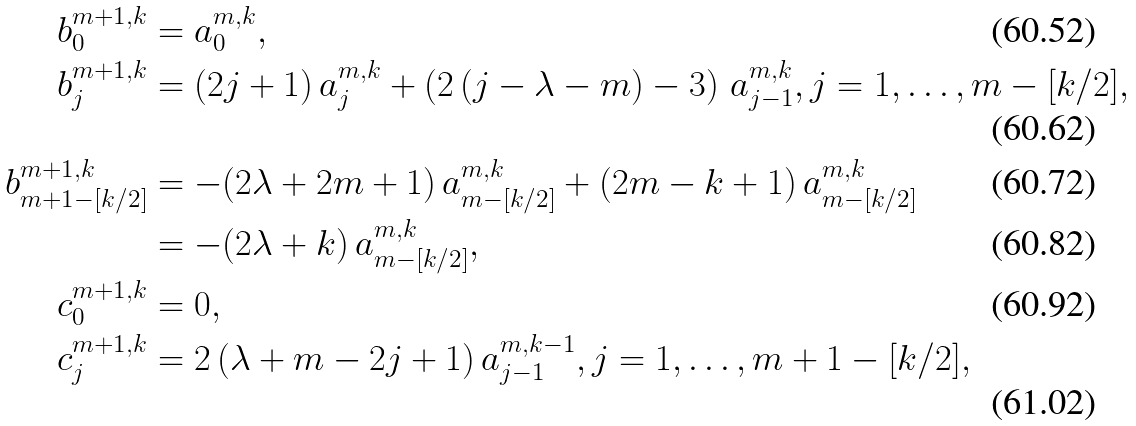Convert formula to latex. <formula><loc_0><loc_0><loc_500><loc_500>b _ { 0 } ^ { m + 1 , k } & = a _ { 0 } ^ { m , k } , \\ b _ { j } ^ { m + 1 , k } & = ( 2 j + 1 ) \, a _ { j } ^ { m , k } + \left ( 2 \, ( j - \lambda - m ) - 3 \right ) \, a _ { j - 1 } ^ { m , k } , j = 1 , \dots , m - [ k / 2 ] , \\ b _ { m + 1 - [ k / 2 ] } ^ { m + 1 , k } & = - ( 2 \lambda + 2 m + 1 ) \, a _ { m - [ k / 2 ] } ^ { m , k } + ( 2 m - k + 1 ) \, a _ { m - [ k / 2 ] } ^ { m , k } \\ & = - ( 2 \lambda + k ) \, a _ { m - [ k / 2 ] } ^ { m , k } , \\ c _ { 0 } ^ { m + 1 , k } & = 0 , \\ c _ { j } ^ { m + 1 , k } & = 2 \, ( \lambda + m - 2 j + 1 ) \, a _ { j - 1 } ^ { m , k - 1 } , j = 1 , \dots , m + 1 - [ k / 2 ] ,</formula> 